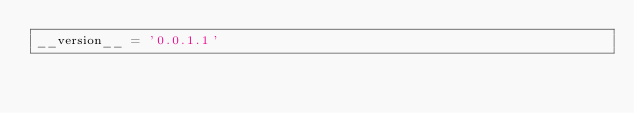<code> <loc_0><loc_0><loc_500><loc_500><_Python_>__version__ = '0.0.1.1'
</code> 